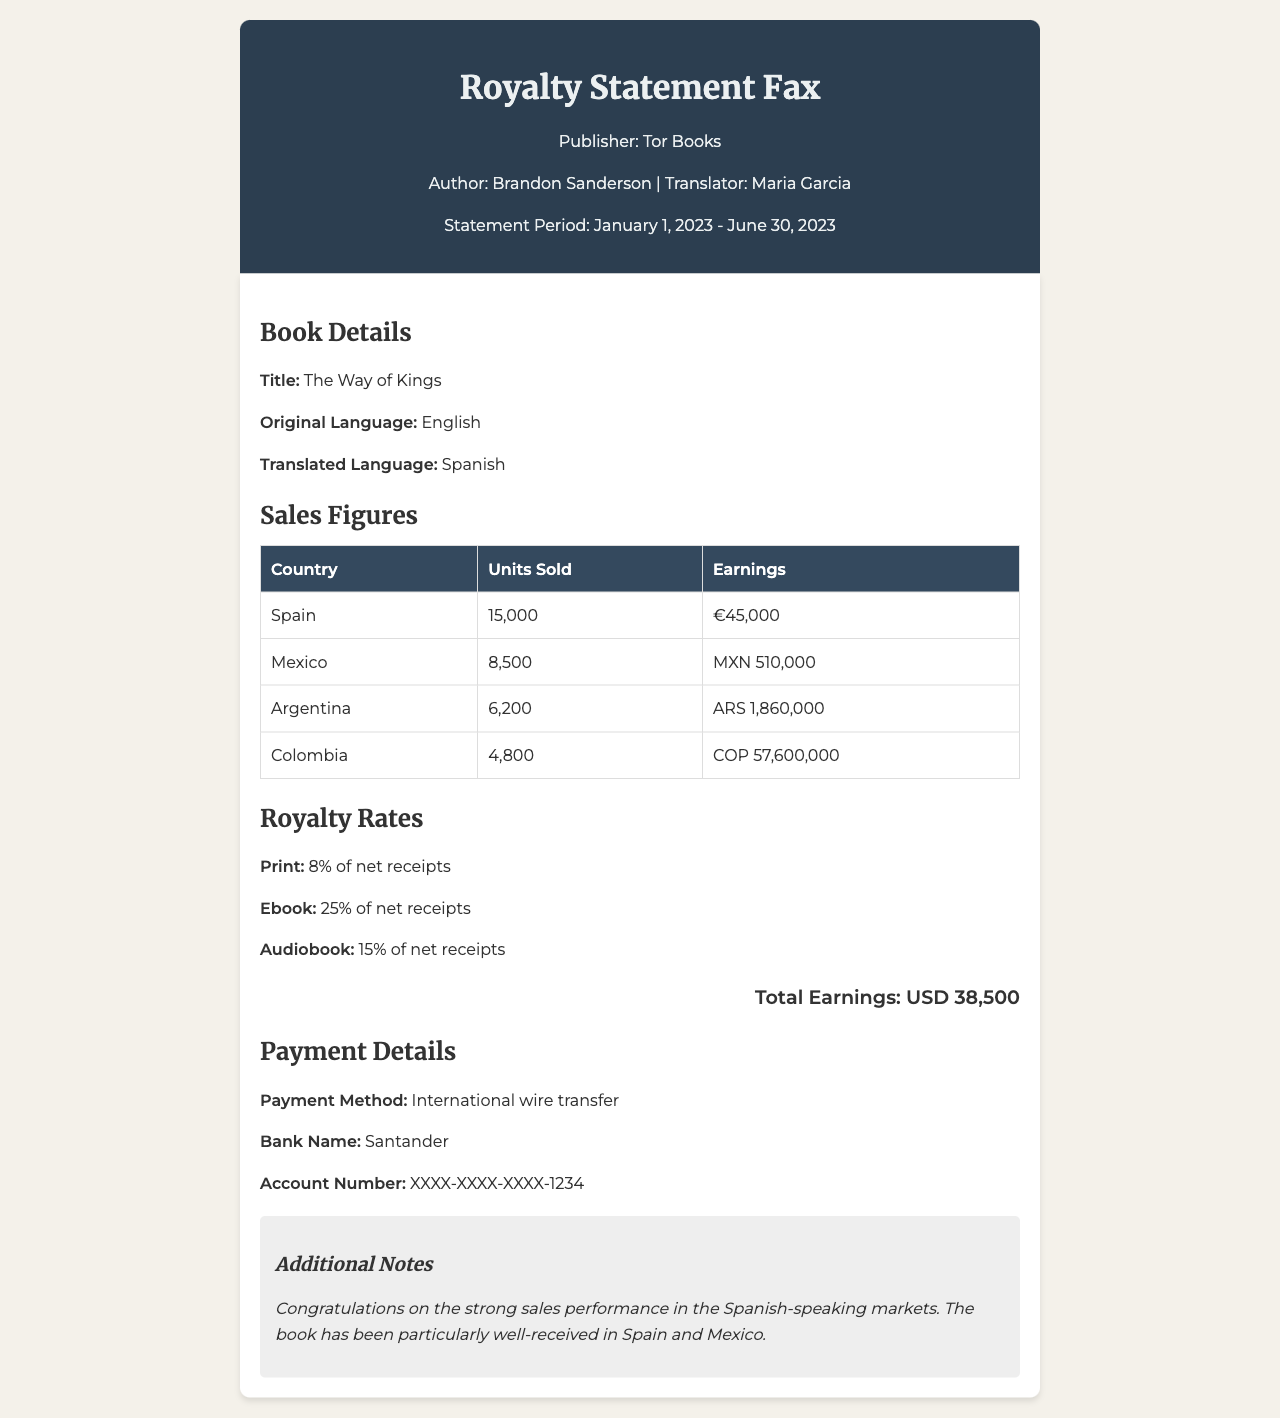What is the title of the book? The title of the book is mentioned in the book details section of the document.
Answer: The Way of Kings Who is the translator? The translator's name is provided in the fax header.
Answer: Maria Garcia What is the total number of units sold in Spain? The units sold in Spain are listed in the sales figures table.
Answer: 15,000 What is the earnings figure for Mexico in MXN? The earnings for Mexico are specified in the sales figures table using the MXN currency.
Answer: MXN 510,000 Which country sold the least number of units? The sales figures table shows the units sold for each country, allowing for comparison.
Answer: Colombia What percentage is the royalty rate for ebooks? The royalty rates section provides specific percentages for different formats.
Answer: 25% How is the payment made? The payment details section indicates the method of payment.
Answer: International wire transfer What was the statement period for this royalty statement? The statement period is mentioned in the fax header at the top of the document.
Answer: January 1, 2023 - June 30, 2023 What is the total earnings amount? The total earnings figure is displayed in the total earnings section.
Answer: USD 38,500 